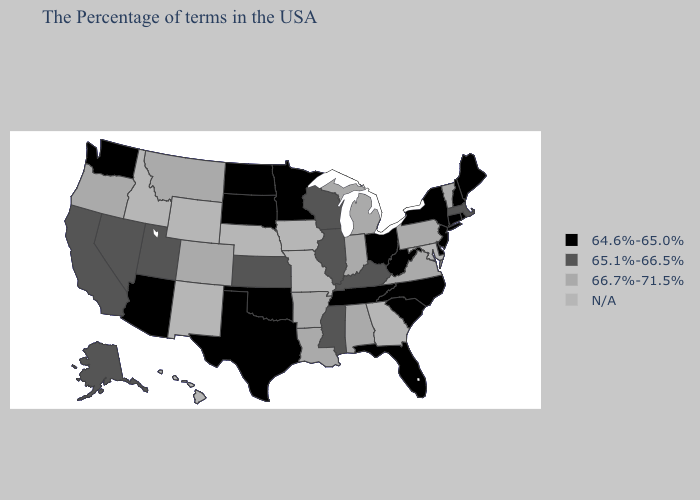What is the value of Connecticut?
Concise answer only. 64.6%-65.0%. Does Arkansas have the highest value in the South?
Give a very brief answer. Yes. Does Connecticut have the lowest value in the Northeast?
Give a very brief answer. Yes. Does Arizona have the lowest value in the West?
Short answer required. Yes. Name the states that have a value in the range 64.6%-65.0%?
Be succinct. Maine, Rhode Island, New Hampshire, Connecticut, New York, New Jersey, Delaware, North Carolina, South Carolina, West Virginia, Ohio, Florida, Tennessee, Minnesota, Oklahoma, Texas, South Dakota, North Dakota, Arizona, Washington. Does the map have missing data?
Give a very brief answer. Yes. Which states have the lowest value in the USA?
Concise answer only. Maine, Rhode Island, New Hampshire, Connecticut, New York, New Jersey, Delaware, North Carolina, South Carolina, West Virginia, Ohio, Florida, Tennessee, Minnesota, Oklahoma, Texas, South Dakota, North Dakota, Arizona, Washington. Which states have the highest value in the USA?
Short answer required. Vermont, Pennsylvania, Virginia, Michigan, Indiana, Alabama, Louisiana, Arkansas, Colorado, Montana, Oregon. Which states have the lowest value in the USA?
Give a very brief answer. Maine, Rhode Island, New Hampshire, Connecticut, New York, New Jersey, Delaware, North Carolina, South Carolina, West Virginia, Ohio, Florida, Tennessee, Minnesota, Oklahoma, Texas, South Dakota, North Dakota, Arizona, Washington. What is the value of Rhode Island?
Short answer required. 64.6%-65.0%. Does Oregon have the highest value in the West?
Give a very brief answer. Yes. Among the states that border Idaho , does Utah have the lowest value?
Answer briefly. No. Does Kentucky have the lowest value in the South?
Keep it brief. No. What is the lowest value in the USA?
Concise answer only. 64.6%-65.0%. 